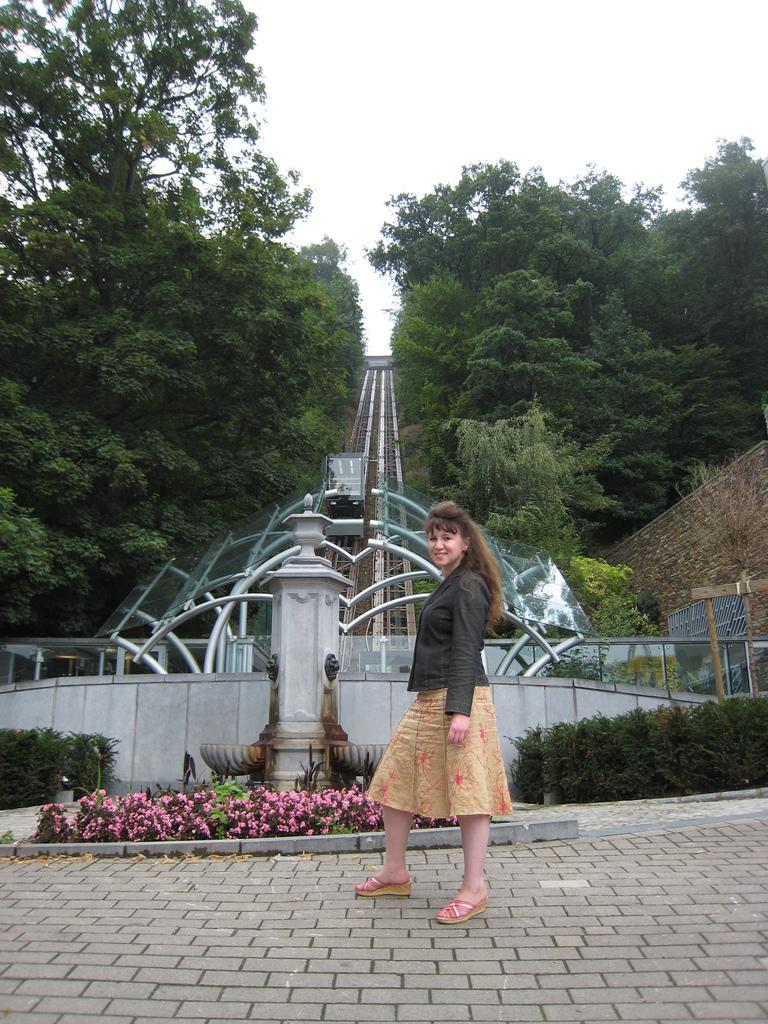Could you give a brief overview of what you see in this image? In this image, we can see a woman is standing on the floor and smiling. Background we can see pillar, few plants, flowers. Here we can see so many trees. Top of the image, there is a sky. 